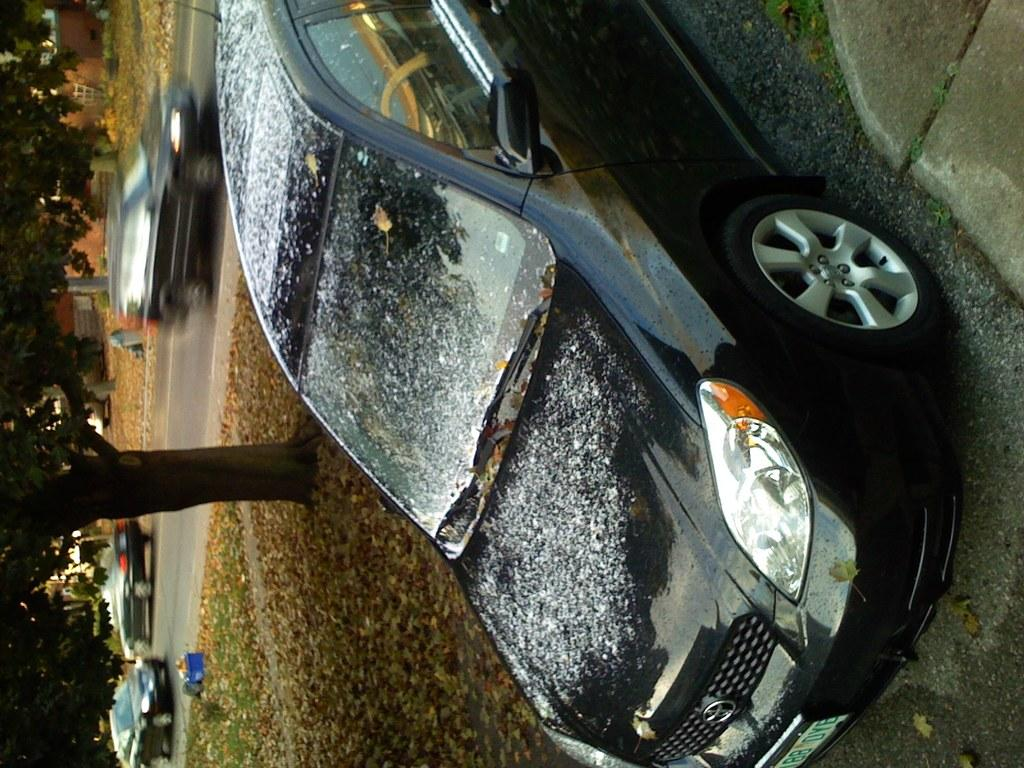What is the main subject in the foreground of the image? There is a car in the foreground of the image. Where is the car located? The car is on the road. What can be seen in the background of the image? There are vehicles moving in the background of the image, as well as buildings. What type of vegetation is visible near the road? There is a tree visible to the side of the road. What type of metal is the ship made of in the image? There is no ship present in the image; it features a car on the road with other vehicles and buildings in the background. 